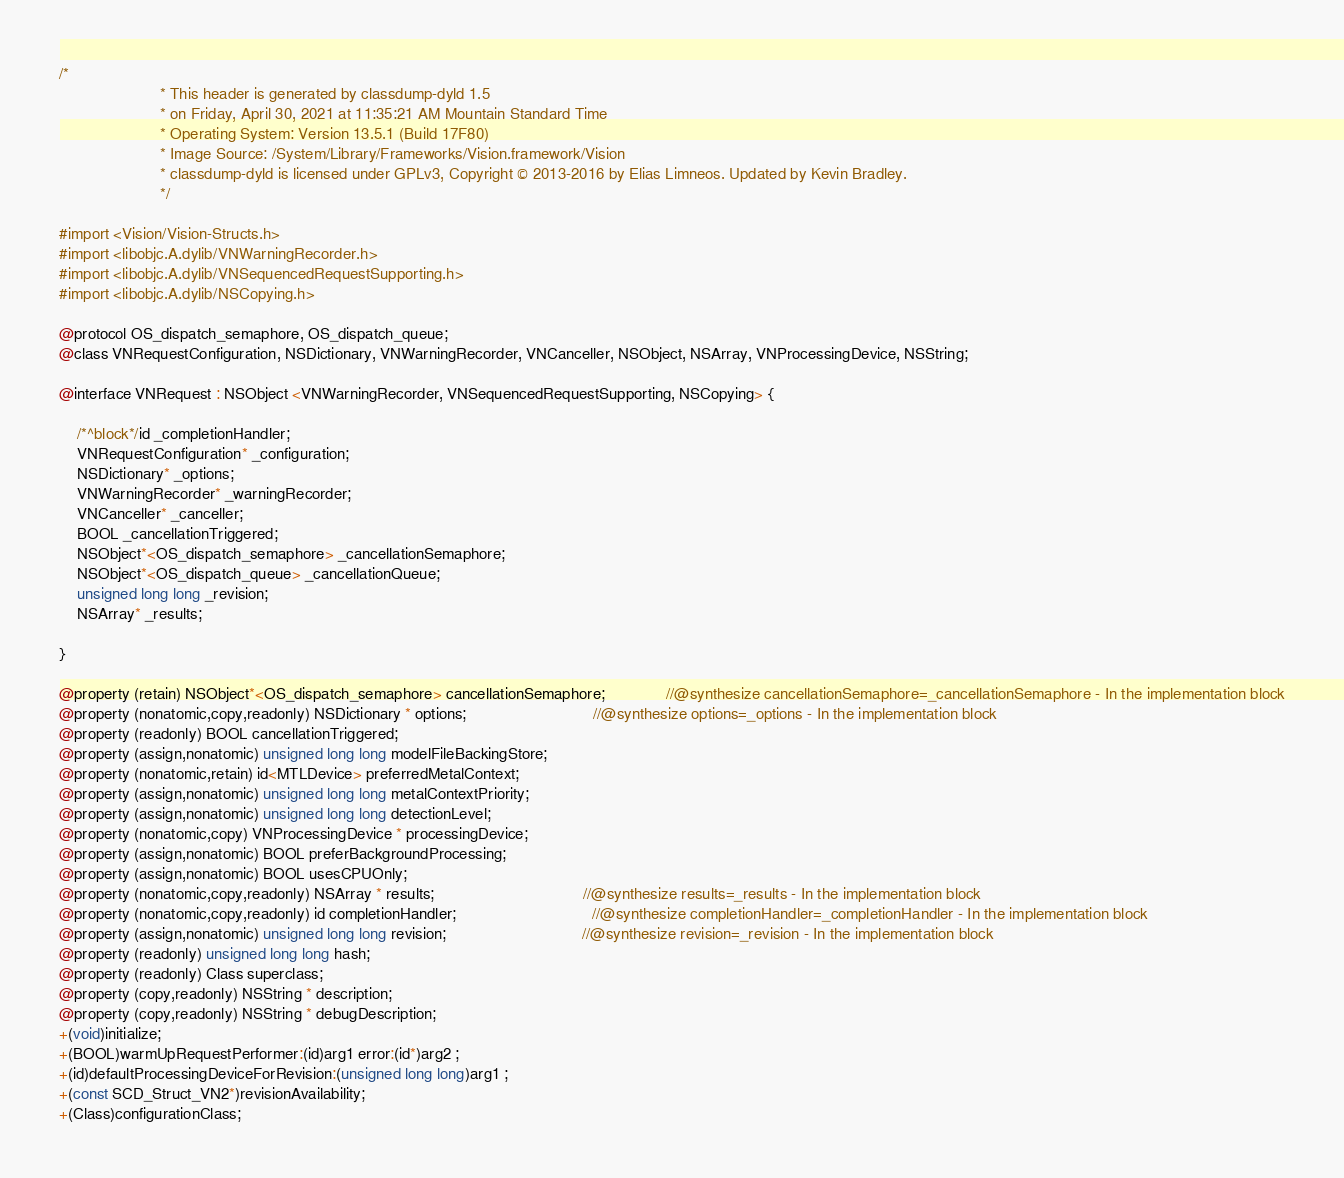Convert code to text. <code><loc_0><loc_0><loc_500><loc_500><_C_>/*
                       * This header is generated by classdump-dyld 1.5
                       * on Friday, April 30, 2021 at 11:35:21 AM Mountain Standard Time
                       * Operating System: Version 13.5.1 (Build 17F80)
                       * Image Source: /System/Library/Frameworks/Vision.framework/Vision
                       * classdump-dyld is licensed under GPLv3, Copyright © 2013-2016 by Elias Limneos. Updated by Kevin Bradley.
                       */

#import <Vision/Vision-Structs.h>
#import <libobjc.A.dylib/VNWarningRecorder.h>
#import <libobjc.A.dylib/VNSequencedRequestSupporting.h>
#import <libobjc.A.dylib/NSCopying.h>

@protocol OS_dispatch_semaphore, OS_dispatch_queue;
@class VNRequestConfiguration, NSDictionary, VNWarningRecorder, VNCanceller, NSObject, NSArray, VNProcessingDevice, NSString;

@interface VNRequest : NSObject <VNWarningRecorder, VNSequencedRequestSupporting, NSCopying> {

	/*^block*/id _completionHandler;
	VNRequestConfiguration* _configuration;
	NSDictionary* _options;
	VNWarningRecorder* _warningRecorder;
	VNCanceller* _canceller;
	BOOL _cancellationTriggered;
	NSObject*<OS_dispatch_semaphore> _cancellationSemaphore;
	NSObject*<OS_dispatch_queue> _cancellationQueue;
	unsigned long long _revision;
	NSArray* _results;

}

@property (retain) NSObject*<OS_dispatch_semaphore> cancellationSemaphore;              //@synthesize cancellationSemaphore=_cancellationSemaphore - In the implementation block
@property (nonatomic,copy,readonly) NSDictionary * options;                             //@synthesize options=_options - In the implementation block
@property (readonly) BOOL cancellationTriggered; 
@property (assign,nonatomic) unsigned long long modelFileBackingStore; 
@property (nonatomic,retain) id<MTLDevice> preferredMetalContext; 
@property (assign,nonatomic) unsigned long long metalContextPriority; 
@property (assign,nonatomic) unsigned long long detectionLevel; 
@property (nonatomic,copy) VNProcessingDevice * processingDevice; 
@property (assign,nonatomic) BOOL preferBackgroundProcessing; 
@property (assign,nonatomic) BOOL usesCPUOnly; 
@property (nonatomic,copy,readonly) NSArray * results;                                  //@synthesize results=_results - In the implementation block
@property (nonatomic,copy,readonly) id completionHandler;                               //@synthesize completionHandler=_completionHandler - In the implementation block
@property (assign,nonatomic) unsigned long long revision;                               //@synthesize revision=_revision - In the implementation block
@property (readonly) unsigned long long hash; 
@property (readonly) Class superclass; 
@property (copy,readonly) NSString * description; 
@property (copy,readonly) NSString * debugDescription; 
+(void)initialize;
+(BOOL)warmUpRequestPerformer:(id)arg1 error:(id*)arg2 ;
+(id)defaultProcessingDeviceForRevision:(unsigned long long)arg1 ;
+(const SCD_Struct_VN2*)revisionAvailability;
+(Class)configurationClass;</code> 